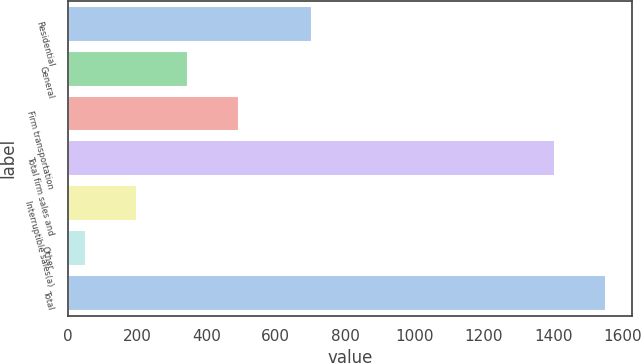Convert chart to OTSL. <chart><loc_0><loc_0><loc_500><loc_500><bar_chart><fcel>Residential<fcel>General<fcel>Firm transportation<fcel>Total firm sales and<fcel>Interruptible sales(a)<fcel>Other<fcel>Total<nl><fcel>704<fcel>345.8<fcel>492.7<fcel>1404<fcel>198.9<fcel>52<fcel>1550.9<nl></chart> 